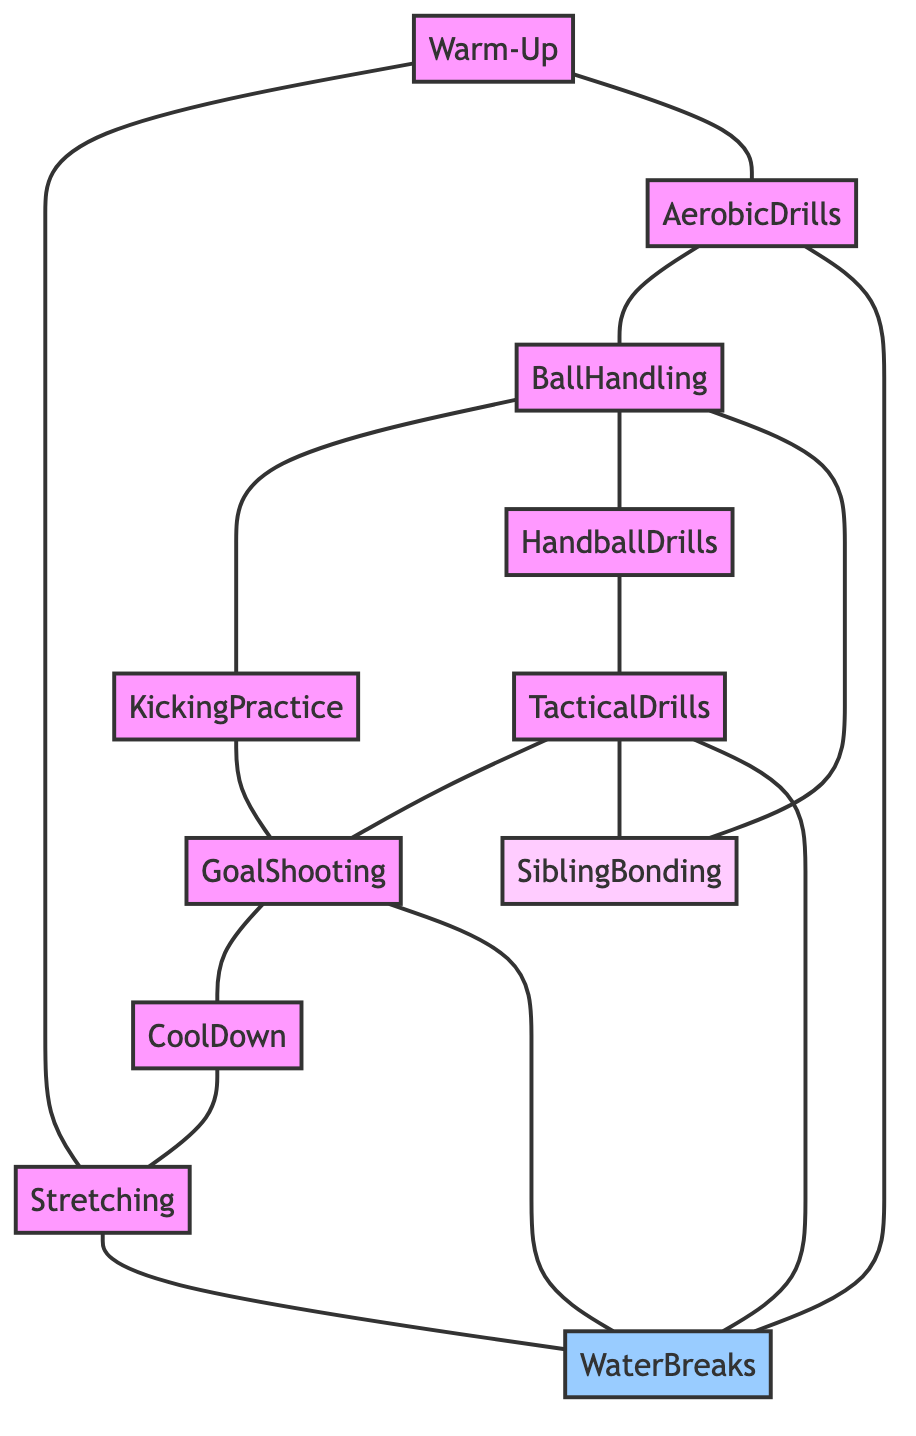What's the total number of nodes in the diagram? By counting the unique items listed under "nodes," we see there are 11 distinct activities or concepts related to the training routine.
Answer: 11 What activities are directly connected to Water Breaks? Looking at the edges, Water Breaks connects to Stretching, Aerobic Drills, Tactical Drills, and Goal Shooting; those are the activities listed directly linked to Water Breaks.
Answer: Stretching, Aerobic Drills, Tactical Drills, Goal Shooting Which activity comes immediately after Kicking Practice? Examining the edges, Kicking Practice connects to Goal Shooting directly, indicating that it's the subsequent step following Kicking Practice.
Answer: Goal Shooting How many edges connect to Sibling Bonding? By analyzing the connections, Sibling Bonding has links from Tactical Drills and Ball Handling, giving it a total of 2 edges connecting it.
Answer: 2 What is the last activity before Cool Down? Looking at the edges leading into Cool Down, the connecting edge comes from Goal Shooting, which identifies it as the activity right before the Cool Down.
Answer: Goal Shooting Which two activities connect to both Handball Drills and Sibling Bonding? Handball Drills connects with Tactical Drills, and Sibling Bonding is connected to Tactical Drills and Ball Handling; thus, both connect to Tactical Drills.
Answer: Tactical Drills Is there any direct relationship between Aerobic Drills and Goal Shooting? Checking through the edges, there is no direct link between Aerobic Drills and Goal Shooting; hence, they are not directly related in this diagram.
Answer: No What activities share a connection with Stretching? Stretching connects directly to Warm-Up, Cool Down, and Water Breaks, as indicated by the edges showing those relationships.
Answer: Warm-Up, Cool Down, Water Breaks Which two activities are not connected by any edges? Analyzing the structure, it appears that both Water Breaks and Sibling Bonding do not have any direct connections with each other based on the given edges.
Answer: None 